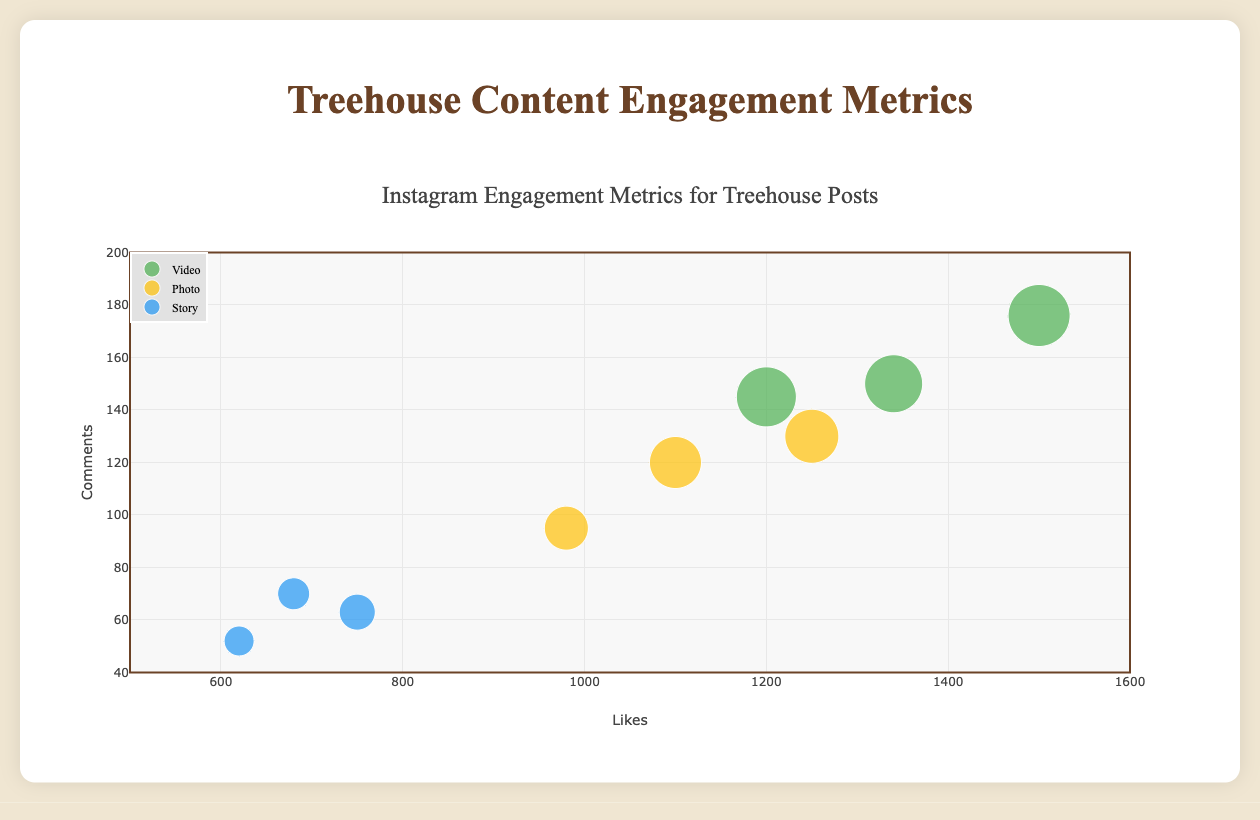What is the color associated with Photo posts? The legend in the scatter plot indicates the color coding for different content types. According to the legend, Photo posts are shown in yellow.
Answer: Yellow How many data points represent Story posts in the plot? The legend shows the marker symbols for each content type. By counting the number of distinct markers representing "Story," we see there are three posts (C003, C006, C009).
Answer: Three Which video post received the highest number of comments? Observing the scatter plot, the data point with the highest 'y' value (comments) among the video points is C004, "Treehouse Getaway in New Zealand" with 176 comments.
Answer: Treehouse Getaway in New Zealand What is the average number of shares for Photo posts? To find the average, locate the shares for photo content (C002, C005, C008). Sum the shares (220 + 260 + 270 = 750). Divide by the number of Photo posts (3).
Answer: 250 shares Which content type generally has larger marker sizes and what does it signify? Marker size represents the number of shares. Observing the scatter plot, Video posts mostly have larger marker sizes, indicating higher shares overall.
Answer: Video Is there a correlation between the number of likes and comments for Videos? By examining the scatter plot, Video posts (green markers) generally show that content with more likes tend to have more comments, e.g., C001 and C004.
Answer: Yes Which post has the smallest marker size and what does it signify? The smallest marker size is C006, representing the post "A Night at the Treehouse Hotel in Thailand", which signifies the least shares (150) among all posts.
Answer: A Night at the Treehouse Hotel in Thailand What content type has the highest engagement in terms of combined likes and comments? Summing likes and comments for all content types: 
Video (1200+145 + 1500+176 + 1340+150 = 4511), 
Photo (980+95 + 1100+120 + 1250+130 = 3675), 
Story (750+63 + 620+52 + 680+70 = 2235). 
Video has the highest combined engagement.
Answer: Video How does the number of likes compare between the top-performing Photo post and the lowest-performing Video post? The top-performing Photo post (C008) has 1250 likes. The lowest-performing Video post (C001) has 1200 likes. 1250 is slightly greater than 1200.
Answer: The Photo post has more likes 